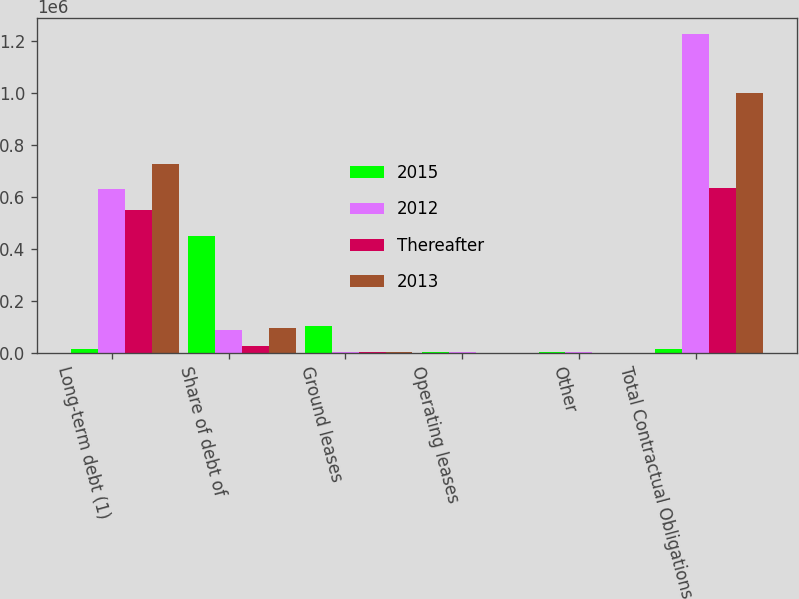Convert chart to OTSL. <chart><loc_0><loc_0><loc_500><loc_500><stacked_bar_chart><ecel><fcel>Long-term debt (1)<fcel>Share of debt of<fcel>Ground leases<fcel>Operating leases<fcel>Other<fcel>Total Contractual Obligations<nl><fcel>2015<fcel>14936.5<fcel>447573<fcel>103563<fcel>2704<fcel>1967<fcel>14936.5<nl><fcel>2012<fcel>629781<fcel>87602<fcel>2199<fcel>840<fcel>1015<fcel>1.2258e+06<nl><fcel>Thereafter<fcel>548966<fcel>27169<fcel>2198<fcel>419<fcel>398<fcel>633481<nl><fcel>2013<fcel>725060<fcel>93663<fcel>2169<fcel>395<fcel>229<fcel>998091<nl></chart> 